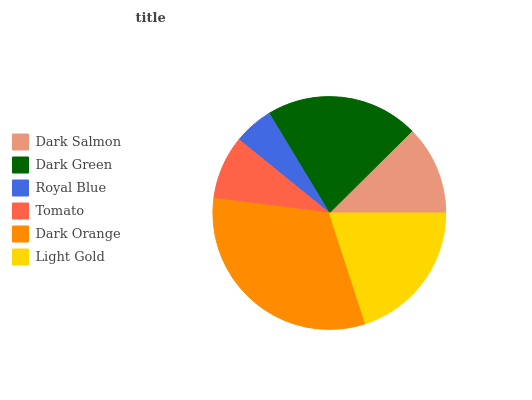Is Royal Blue the minimum?
Answer yes or no. Yes. Is Dark Orange the maximum?
Answer yes or no. Yes. Is Dark Green the minimum?
Answer yes or no. No. Is Dark Green the maximum?
Answer yes or no. No. Is Dark Green greater than Dark Salmon?
Answer yes or no. Yes. Is Dark Salmon less than Dark Green?
Answer yes or no. Yes. Is Dark Salmon greater than Dark Green?
Answer yes or no. No. Is Dark Green less than Dark Salmon?
Answer yes or no. No. Is Light Gold the high median?
Answer yes or no. Yes. Is Dark Salmon the low median?
Answer yes or no. Yes. Is Royal Blue the high median?
Answer yes or no. No. Is Dark Green the low median?
Answer yes or no. No. 